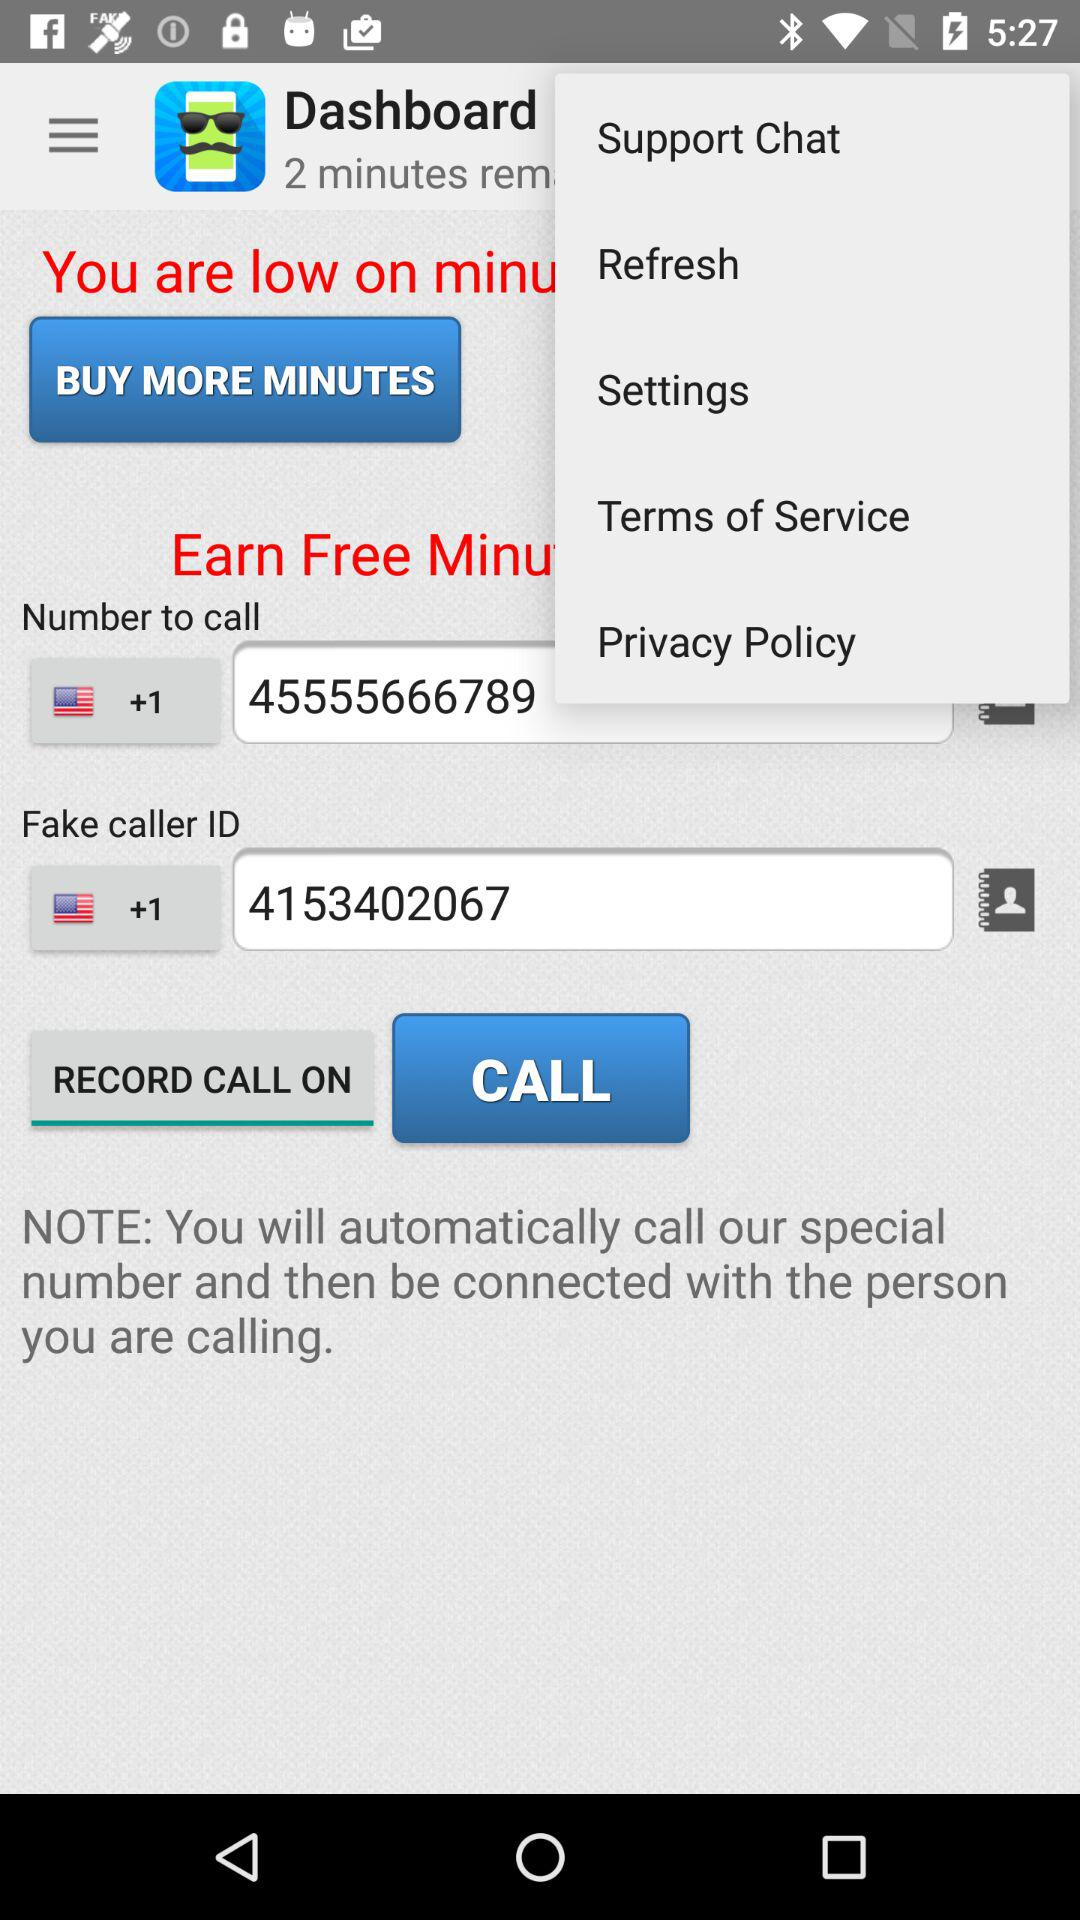What is the number to call? The number to call is +1 45555666789. 